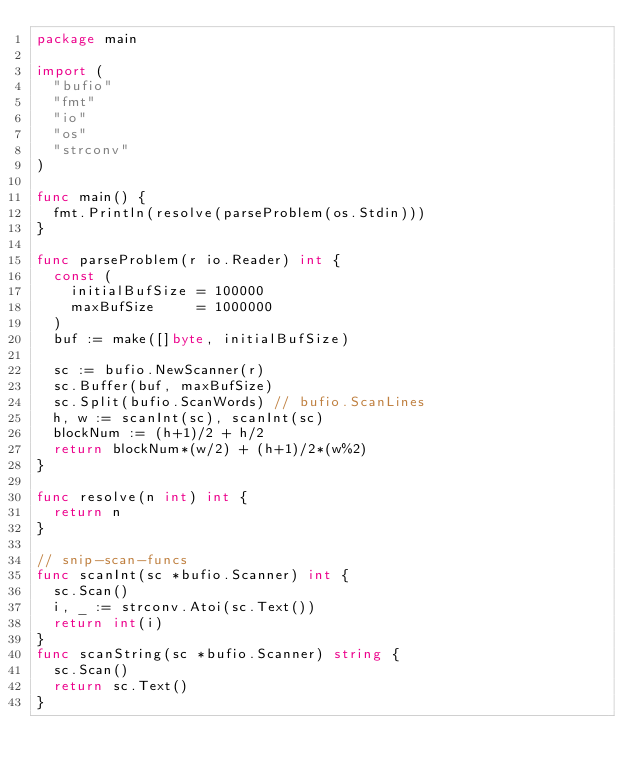<code> <loc_0><loc_0><loc_500><loc_500><_Go_>package main

import (
	"bufio"
	"fmt"
	"io"
	"os"
	"strconv"
)

func main() {
	fmt.Println(resolve(parseProblem(os.Stdin)))
}

func parseProblem(r io.Reader) int {
	const (
		initialBufSize = 100000
		maxBufSize     = 1000000
	)
	buf := make([]byte, initialBufSize)

	sc := bufio.NewScanner(r)
	sc.Buffer(buf, maxBufSize)
	sc.Split(bufio.ScanWords) // bufio.ScanLines
	h, w := scanInt(sc), scanInt(sc)
	blockNum := (h+1)/2 + h/2
	return blockNum*(w/2) + (h+1)/2*(w%2)
}

func resolve(n int) int {
	return n
}

// snip-scan-funcs
func scanInt(sc *bufio.Scanner) int {
	sc.Scan()
	i, _ := strconv.Atoi(sc.Text())
	return int(i)
}
func scanString(sc *bufio.Scanner) string {
	sc.Scan()
	return sc.Text()
}
</code> 